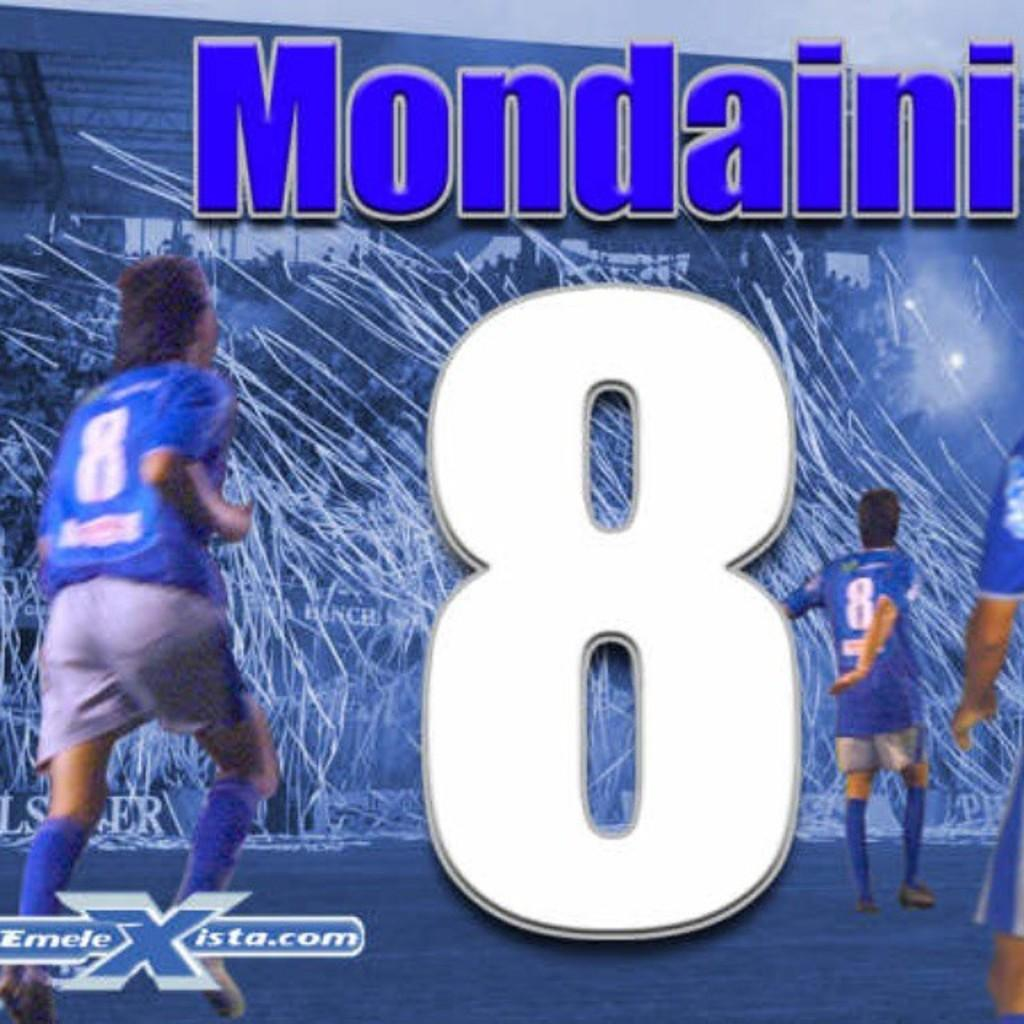Provide a one-sentence caption for the provided image. The blue jersey with the number 8 belongs to Mondaini. 